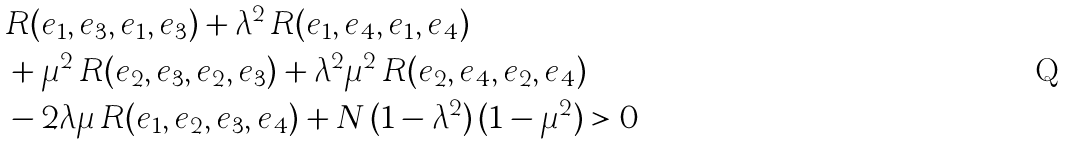Convert formula to latex. <formula><loc_0><loc_0><loc_500><loc_500>& R ( e _ { 1 } , e _ { 3 } , e _ { 1 } , e _ { 3 } ) + \lambda ^ { 2 } \, R ( e _ { 1 } , e _ { 4 } , e _ { 1 } , e _ { 4 } ) \\ & + \mu ^ { 2 } \, R ( e _ { 2 } , e _ { 3 } , e _ { 2 } , e _ { 3 } ) + \lambda ^ { 2 } \mu ^ { 2 } \, R ( e _ { 2 } , e _ { 4 } , e _ { 2 } , e _ { 4 } ) \\ & - 2 \lambda \mu \, R ( e _ { 1 } , e _ { 2 } , e _ { 3 } , e _ { 4 } ) + N \, ( 1 - \lambda ^ { 2 } ) \, ( 1 - \mu ^ { 2 } ) > 0</formula> 